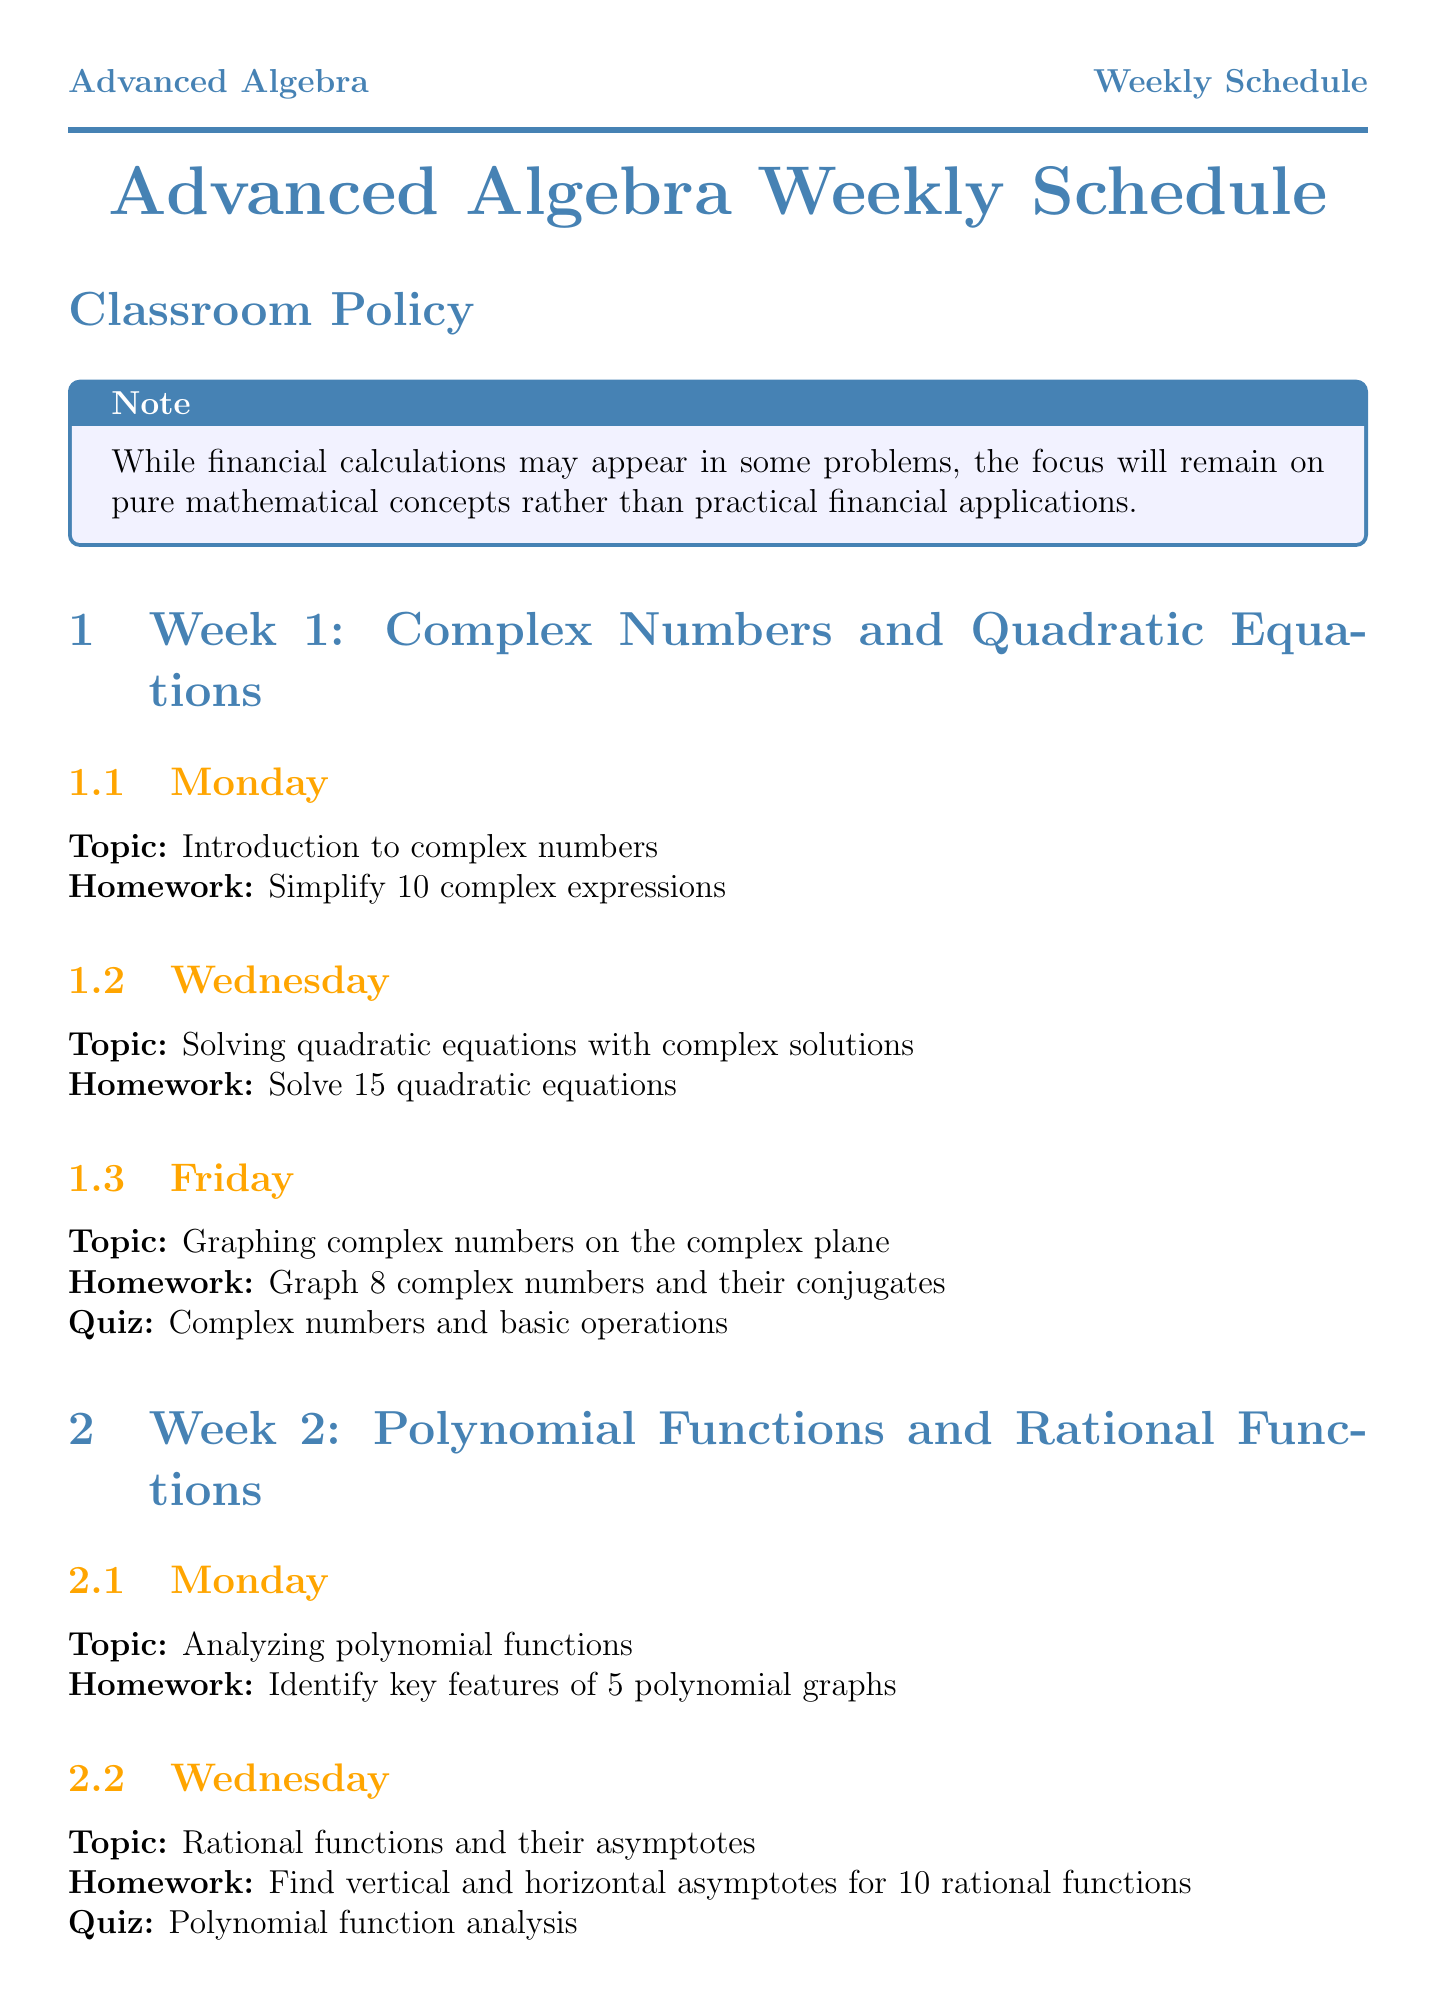What is the topic for week 1? The topic for week 1 is stated at the beginning of the section and is "Complex Numbers and Quadratic Equations."
Answer: Complex Numbers and Quadratic Equations On which day is the quiz for week 2 scheduled? The document specifies the quiz date for each week, and for week 2, it states that the quiz is on Wednesday.
Answer: Wednesday How many complex expressions are assigned for homework in week 1? The homework for Monday in week 1 requires students to simplify 10 complex expressions.
Answer: 10 What percentage do quizzes account for in the final grade? The grading policy section states that quizzes account for 30% of the final grade.
Answer: 30% What is the homework assignment for Wednesday of week 3? The document lists the homework for each lesson, and for Wednesday of week 3, the assignment is to simplify 15 logarithmic expressions.
Answer: Simplify 15 logarithmic expressions How many polynomial and rational inequalities are students required to solve in week 2? The homework assignment on Friday of week 2 indicates that students need to solve 12 polynomial and rational inequalities.
Answer: 12 What online resource is mentioned for advanced algebra help? The document lists additional resources, and one of them is "Khan Academy Advanced Algebra course."
Answer: Khan Academy Advanced Algebra course Which topic is reviewed on Monday of week 4? The lesson content for Monday of week 4 indicates that the review focuses on "basic trigonometric functions."
Answer: basic trigonometric functions How many trigonometric identities must be proved on Wednesday of week 4? The homework for Wednesday of week 4 states that students are required to prove 5 trigonometric identities.
Answer: 5 